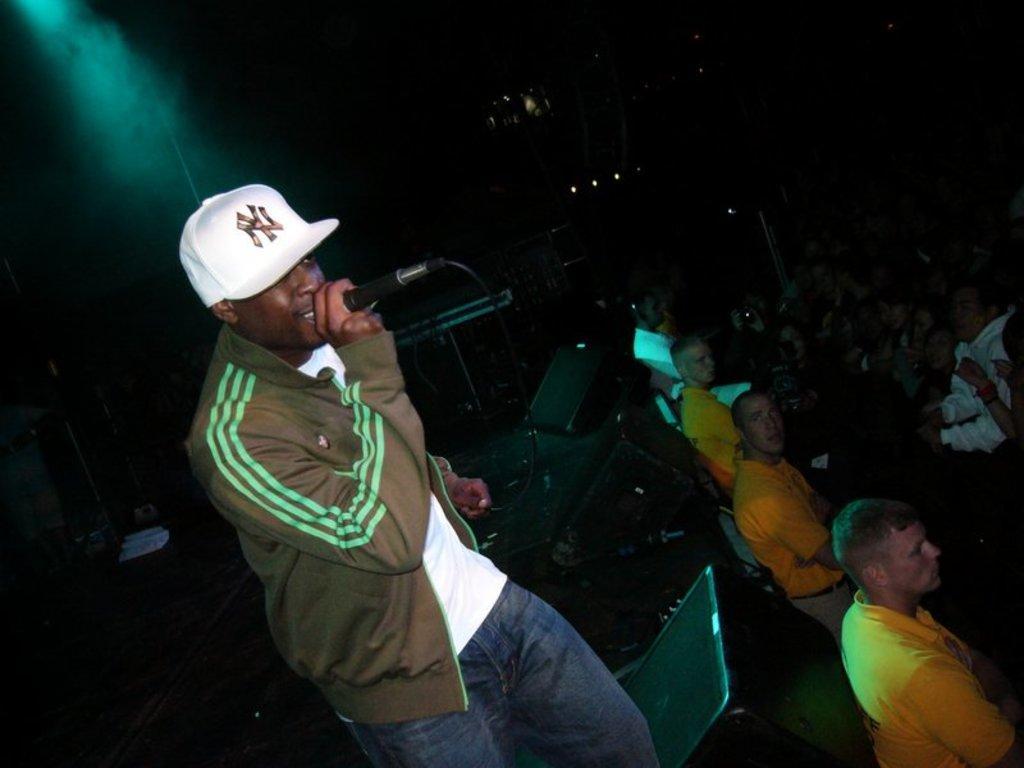Can you describe this image briefly? On the left side of the image we can see a man standing and holding a mic in his hand. At the bottom there are speakers. On the right there is crowd. At the top there are lights. 